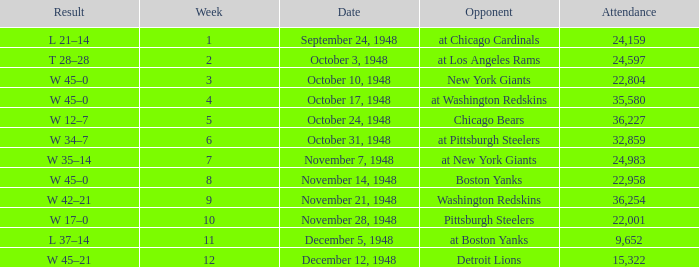What is the lowest value for Week, when the Attendance is greater than 22,958, and when the Opponent is At Chicago Cardinals? 1.0. 